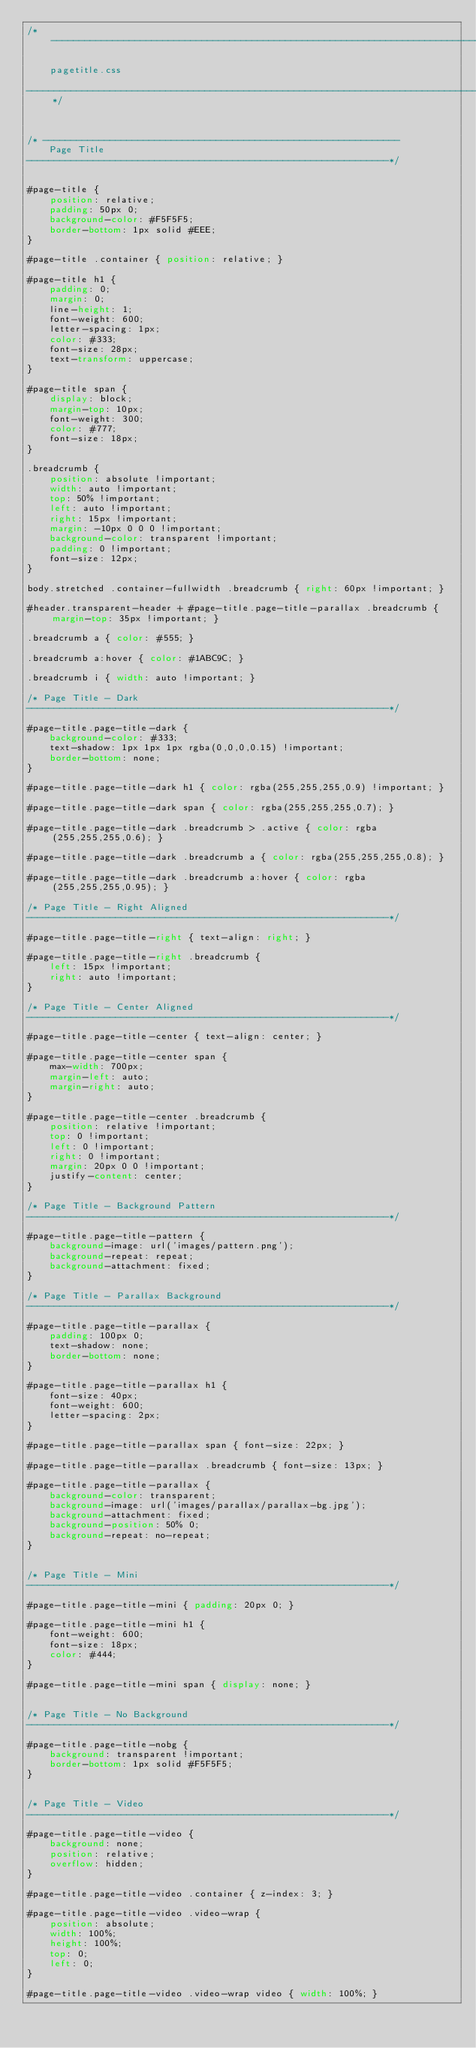<code> <loc_0><loc_0><loc_500><loc_500><_CSS_>/*-----------------------------------------------------------------------------------

	pagetitle.css

-----------------------------------------------------------------------------------*/



/* ----------------------------------------------------------------
	Page Title
-----------------------------------------------------------------*/


#page-title {
	position: relative;
	padding: 50px 0;
	background-color: #F5F5F5;
	border-bottom: 1px solid #EEE;
}

#page-title .container { position: relative; }

#page-title h1 {
	padding: 0;
	margin: 0;
	line-height: 1;
	font-weight: 600;
	letter-spacing: 1px;
	color: #333;
	font-size: 28px;
	text-transform: uppercase;
}

#page-title span {
	display: block;
	margin-top: 10px;
	font-weight: 300;
	color: #777;
	font-size: 18px;
}

.breadcrumb {
	position: absolute !important;
	width: auto !important;
	top: 50% !important;
	left: auto !important;
	right: 15px !important;
	margin: -10px 0 0 0 !important;
	background-color: transparent !important;
	padding: 0 !important;
	font-size: 12px;
}

body.stretched .container-fullwidth .breadcrumb { right: 60px !important; }

#header.transparent-header + #page-title.page-title-parallax .breadcrumb { margin-top: 35px !important; }

.breadcrumb a { color: #555; }

.breadcrumb a:hover { color: #1ABC9C; }

.breadcrumb i { width: auto !important; }

/* Page Title - Dark
-----------------------------------------------------------------*/

#page-title.page-title-dark {
	background-color: #333;
	text-shadow: 1px 1px 1px rgba(0,0,0,0.15) !important;
	border-bottom: none;
}

#page-title.page-title-dark h1 { color: rgba(255,255,255,0.9) !important; }

#page-title.page-title-dark span { color: rgba(255,255,255,0.7); }

#page-title.page-title-dark .breadcrumb > .active { color: rgba(255,255,255,0.6); }

#page-title.page-title-dark .breadcrumb a { color: rgba(255,255,255,0.8); }

#page-title.page-title-dark .breadcrumb a:hover { color: rgba(255,255,255,0.95); }

/* Page Title - Right Aligned
-----------------------------------------------------------------*/

#page-title.page-title-right { text-align: right; }

#page-title.page-title-right .breadcrumb {
	left: 15px !important;
	right: auto !important;
}

/* Page Title - Center Aligned
-----------------------------------------------------------------*/

#page-title.page-title-center { text-align: center; }

#page-title.page-title-center span {
	max-width: 700px;
	margin-left: auto;
	margin-right: auto;
}

#page-title.page-title-center .breadcrumb {
	position: relative !important;
	top: 0 !important;
	left: 0 !important;
	right: 0 !important;
	margin: 20px 0 0 !important;
	justify-content: center;
}

/* Page Title - Background Pattern
-----------------------------------------------------------------*/

#page-title.page-title-pattern {
	background-image: url('images/pattern.png');
	background-repeat: repeat;
	background-attachment: fixed;
}

/* Page Title - Parallax Background
-----------------------------------------------------------------*/

#page-title.page-title-parallax {
	padding: 100px 0;
	text-shadow: none;
	border-bottom: none;
}

#page-title.page-title-parallax h1 {
	font-size: 40px;
	font-weight: 600;
	letter-spacing: 2px;
}

#page-title.page-title-parallax span { font-size: 22px; }

#page-title.page-title-parallax .breadcrumb { font-size: 13px; }

#page-title.page-title-parallax {
	background-color: transparent;
	background-image: url('images/parallax/parallax-bg.jpg');
	background-attachment: fixed;
	background-position: 50% 0;
	background-repeat: no-repeat;
}


/* Page Title - Mini
-----------------------------------------------------------------*/

#page-title.page-title-mini { padding: 20px 0; }

#page-title.page-title-mini h1 {
	font-weight: 600;
	font-size: 18px;
	color: #444;
}

#page-title.page-title-mini span { display: none; }


/* Page Title - No Background
-----------------------------------------------------------------*/

#page-title.page-title-nobg {
	background: transparent !important;
	border-bottom: 1px solid #F5F5F5;
}


/* Page Title - Video
-----------------------------------------------------------------*/

#page-title.page-title-video {
	background: none;
	position: relative;
	overflow: hidden;
}

#page-title.page-title-video .container { z-index: 3; }

#page-title.page-title-video .video-wrap {
	position: absolute;
	width: 100%;
	height: 100%;
	top: 0;
	left: 0;
}

#page-title.page-title-video .video-wrap video { width: 100%; }
</code> 